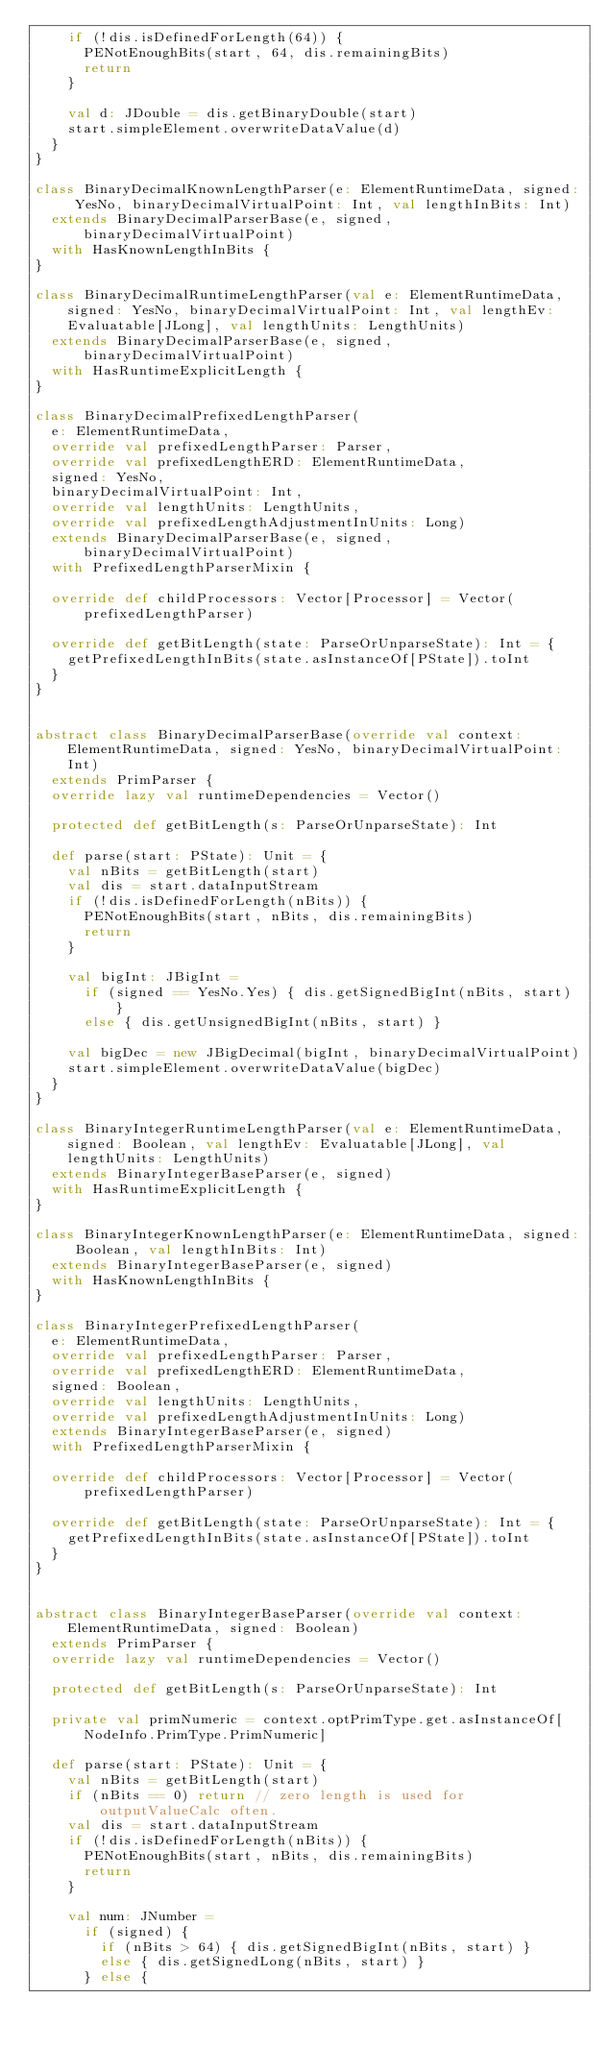Convert code to text. <code><loc_0><loc_0><loc_500><loc_500><_Scala_>    if (!dis.isDefinedForLength(64)) {
      PENotEnoughBits(start, 64, dis.remainingBits)
      return
    }

    val d: JDouble = dis.getBinaryDouble(start)
    start.simpleElement.overwriteDataValue(d)
  }
}

class BinaryDecimalKnownLengthParser(e: ElementRuntimeData, signed: YesNo, binaryDecimalVirtualPoint: Int, val lengthInBits: Int)
  extends BinaryDecimalParserBase(e, signed, binaryDecimalVirtualPoint)
  with HasKnownLengthInBits {
}

class BinaryDecimalRuntimeLengthParser(val e: ElementRuntimeData, signed: YesNo, binaryDecimalVirtualPoint: Int, val lengthEv: Evaluatable[JLong], val lengthUnits: LengthUnits)
  extends BinaryDecimalParserBase(e, signed, binaryDecimalVirtualPoint)
  with HasRuntimeExplicitLength {
}

class BinaryDecimalPrefixedLengthParser(
  e: ElementRuntimeData,
  override val prefixedLengthParser: Parser,
  override val prefixedLengthERD: ElementRuntimeData,
  signed: YesNo,
  binaryDecimalVirtualPoint: Int,
  override val lengthUnits: LengthUnits,
  override val prefixedLengthAdjustmentInUnits: Long)
  extends BinaryDecimalParserBase(e, signed, binaryDecimalVirtualPoint)
  with PrefixedLengthParserMixin {

  override def childProcessors: Vector[Processor] = Vector(prefixedLengthParser)
      
  override def getBitLength(state: ParseOrUnparseState): Int = {
    getPrefixedLengthInBits(state.asInstanceOf[PState]).toInt
  }
}


abstract class BinaryDecimalParserBase(override val context: ElementRuntimeData, signed: YesNo, binaryDecimalVirtualPoint: Int)
  extends PrimParser {
  override lazy val runtimeDependencies = Vector()

  protected def getBitLength(s: ParseOrUnparseState): Int

  def parse(start: PState): Unit = {
    val nBits = getBitLength(start)
    val dis = start.dataInputStream
    if (!dis.isDefinedForLength(nBits)) {
      PENotEnoughBits(start, nBits, dis.remainingBits)
      return
    }

    val bigInt: JBigInt =
      if (signed == YesNo.Yes) { dis.getSignedBigInt(nBits, start) }
      else { dis.getUnsignedBigInt(nBits, start) }

    val bigDec = new JBigDecimal(bigInt, binaryDecimalVirtualPoint)
    start.simpleElement.overwriteDataValue(bigDec)
  }
}

class BinaryIntegerRuntimeLengthParser(val e: ElementRuntimeData, signed: Boolean, val lengthEv: Evaluatable[JLong], val lengthUnits: LengthUnits)
  extends BinaryIntegerBaseParser(e, signed)
  with HasRuntimeExplicitLength {
}

class BinaryIntegerKnownLengthParser(e: ElementRuntimeData, signed: Boolean, val lengthInBits: Int)
  extends BinaryIntegerBaseParser(e, signed)
  with HasKnownLengthInBits {
}

class BinaryIntegerPrefixedLengthParser(
  e: ElementRuntimeData,
  override val prefixedLengthParser: Parser,
  override val prefixedLengthERD: ElementRuntimeData,
  signed: Boolean,
  override val lengthUnits: LengthUnits,
  override val prefixedLengthAdjustmentInUnits: Long)
  extends BinaryIntegerBaseParser(e, signed)
  with PrefixedLengthParserMixin {

  override def childProcessors: Vector[Processor] = Vector(prefixedLengthParser)
      
  override def getBitLength(state: ParseOrUnparseState): Int = {
    getPrefixedLengthInBits(state.asInstanceOf[PState]).toInt
  }
}


abstract class BinaryIntegerBaseParser(override val context: ElementRuntimeData, signed: Boolean)
  extends PrimParser {
  override lazy val runtimeDependencies = Vector()

  protected def getBitLength(s: ParseOrUnparseState): Int

  private val primNumeric = context.optPrimType.get.asInstanceOf[NodeInfo.PrimType.PrimNumeric]

  def parse(start: PState): Unit = {
    val nBits = getBitLength(start)
    if (nBits == 0) return // zero length is used for outputValueCalc often.
    val dis = start.dataInputStream
    if (!dis.isDefinedForLength(nBits)) {
      PENotEnoughBits(start, nBits, dis.remainingBits)
      return
    }

    val num: JNumber =
      if (signed) {
        if (nBits > 64) { dis.getSignedBigInt(nBits, start) }
        else { dis.getSignedLong(nBits, start) }
      } else {</code> 